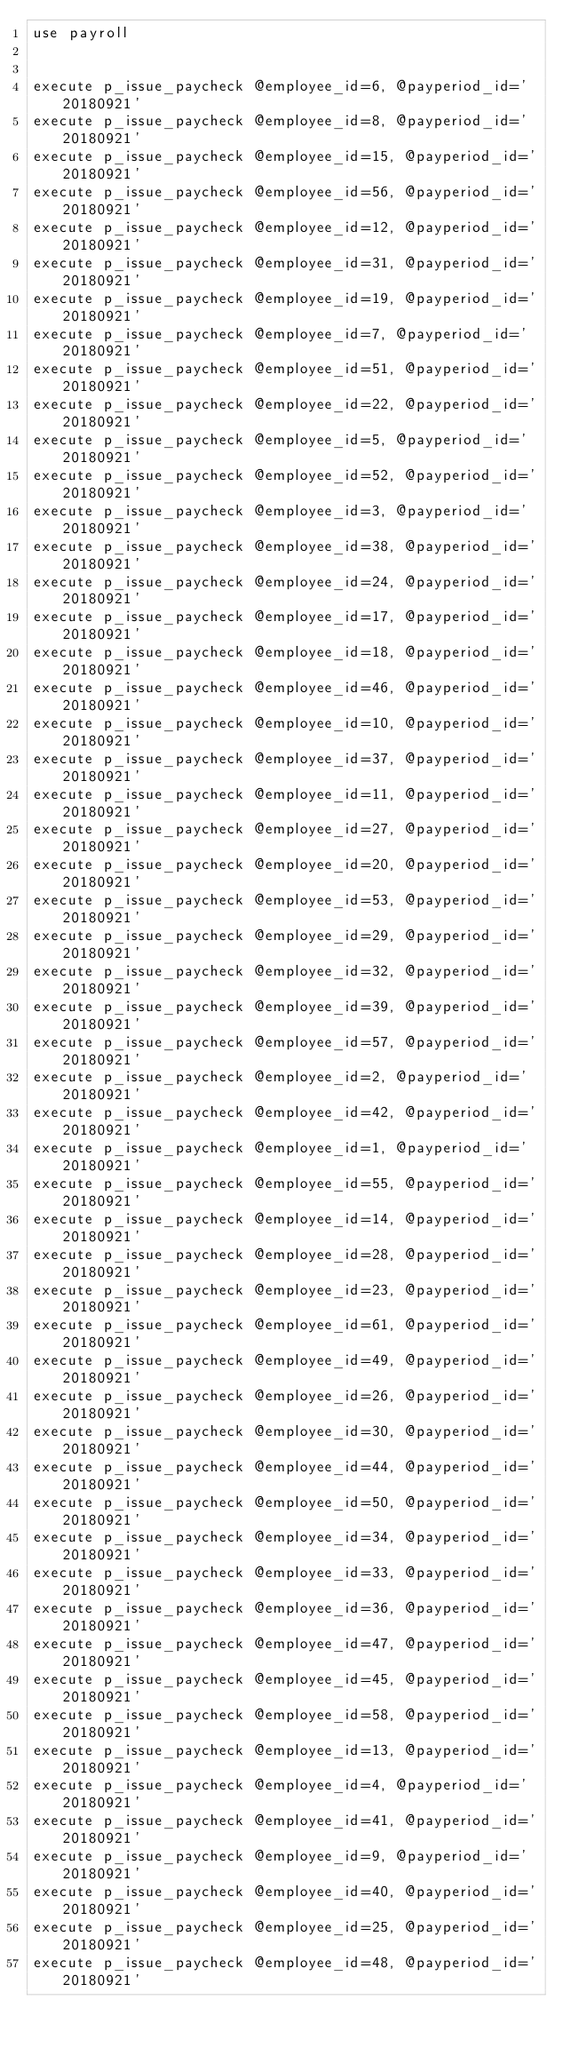<code> <loc_0><loc_0><loc_500><loc_500><_SQL_>use payroll


execute p_issue_paycheck @employee_id=6, @payperiod_id='20180921'
execute p_issue_paycheck @employee_id=8, @payperiod_id='20180921'
execute p_issue_paycheck @employee_id=15, @payperiod_id='20180921'
execute p_issue_paycheck @employee_id=56, @payperiod_id='20180921'
execute p_issue_paycheck @employee_id=12, @payperiod_id='20180921'
execute p_issue_paycheck @employee_id=31, @payperiod_id='20180921'
execute p_issue_paycheck @employee_id=19, @payperiod_id='20180921'
execute p_issue_paycheck @employee_id=7, @payperiod_id='20180921'
execute p_issue_paycheck @employee_id=51, @payperiod_id='20180921'
execute p_issue_paycheck @employee_id=22, @payperiod_id='20180921'
execute p_issue_paycheck @employee_id=5, @payperiod_id='20180921'
execute p_issue_paycheck @employee_id=52, @payperiod_id='20180921'
execute p_issue_paycheck @employee_id=3, @payperiod_id='20180921'
execute p_issue_paycheck @employee_id=38, @payperiod_id='20180921'
execute p_issue_paycheck @employee_id=24, @payperiod_id='20180921'
execute p_issue_paycheck @employee_id=17, @payperiod_id='20180921'
execute p_issue_paycheck @employee_id=18, @payperiod_id='20180921'
execute p_issue_paycheck @employee_id=46, @payperiod_id='20180921'
execute p_issue_paycheck @employee_id=10, @payperiod_id='20180921'
execute p_issue_paycheck @employee_id=37, @payperiod_id='20180921'
execute p_issue_paycheck @employee_id=11, @payperiod_id='20180921'
execute p_issue_paycheck @employee_id=27, @payperiod_id='20180921'
execute p_issue_paycheck @employee_id=20, @payperiod_id='20180921'
execute p_issue_paycheck @employee_id=53, @payperiod_id='20180921'
execute p_issue_paycheck @employee_id=29, @payperiod_id='20180921'
execute p_issue_paycheck @employee_id=32, @payperiod_id='20180921'
execute p_issue_paycheck @employee_id=39, @payperiod_id='20180921'
execute p_issue_paycheck @employee_id=57, @payperiod_id='20180921'
execute p_issue_paycheck @employee_id=2, @payperiod_id='20180921'
execute p_issue_paycheck @employee_id=42, @payperiod_id='20180921'
execute p_issue_paycheck @employee_id=1, @payperiod_id='20180921'
execute p_issue_paycheck @employee_id=55, @payperiod_id='20180921'
execute p_issue_paycheck @employee_id=14, @payperiod_id='20180921'
execute p_issue_paycheck @employee_id=28, @payperiod_id='20180921'
execute p_issue_paycheck @employee_id=23, @payperiod_id='20180921'
execute p_issue_paycheck @employee_id=61, @payperiod_id='20180921'
execute p_issue_paycheck @employee_id=49, @payperiod_id='20180921'
execute p_issue_paycheck @employee_id=26, @payperiod_id='20180921'
execute p_issue_paycheck @employee_id=30, @payperiod_id='20180921'
execute p_issue_paycheck @employee_id=44, @payperiod_id='20180921'
execute p_issue_paycheck @employee_id=50, @payperiod_id='20180921'
execute p_issue_paycheck @employee_id=34, @payperiod_id='20180921'
execute p_issue_paycheck @employee_id=33, @payperiod_id='20180921'
execute p_issue_paycheck @employee_id=36, @payperiod_id='20180921'
execute p_issue_paycheck @employee_id=47, @payperiod_id='20180921'
execute p_issue_paycheck @employee_id=45, @payperiod_id='20180921'
execute p_issue_paycheck @employee_id=58, @payperiod_id='20180921'
execute p_issue_paycheck @employee_id=13, @payperiod_id='20180921'
execute p_issue_paycheck @employee_id=4, @payperiod_id='20180921'
execute p_issue_paycheck @employee_id=41, @payperiod_id='20180921'
execute p_issue_paycheck @employee_id=9, @payperiod_id='20180921'
execute p_issue_paycheck @employee_id=40, @payperiod_id='20180921'
execute p_issue_paycheck @employee_id=25, @payperiod_id='20180921'
execute p_issue_paycheck @employee_id=48, @payperiod_id='20180921'</code> 